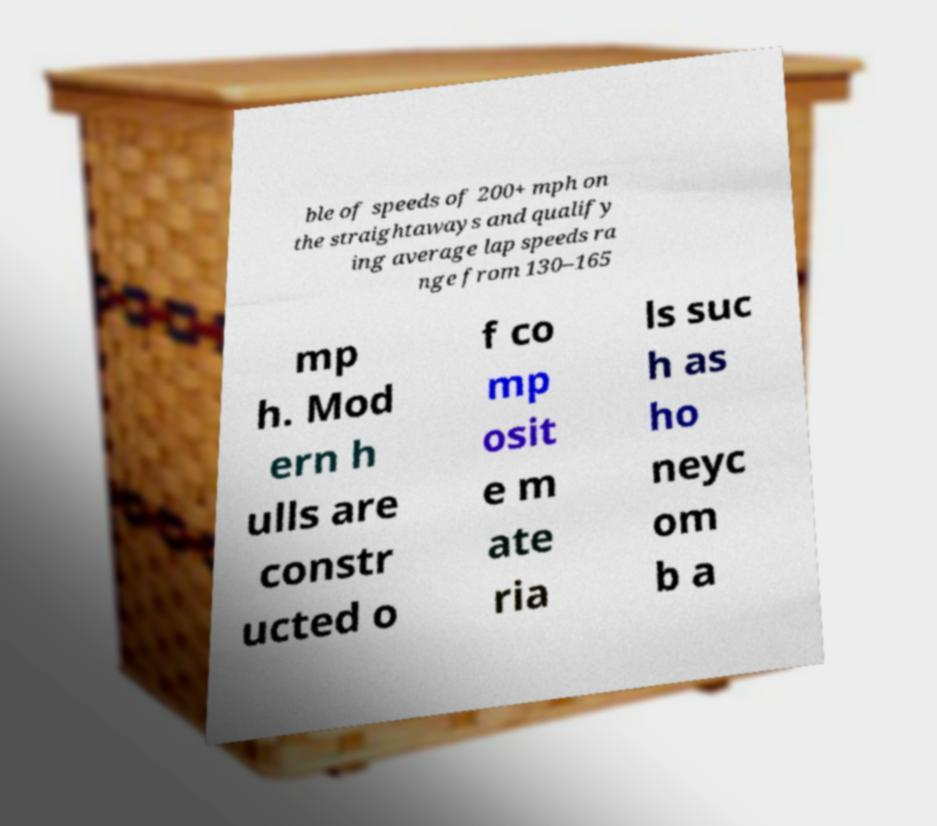Can you accurately transcribe the text from the provided image for me? ble of speeds of 200+ mph on the straightaways and qualify ing average lap speeds ra nge from 130–165 mp h. Mod ern h ulls are constr ucted o f co mp osit e m ate ria ls suc h as ho neyc om b a 